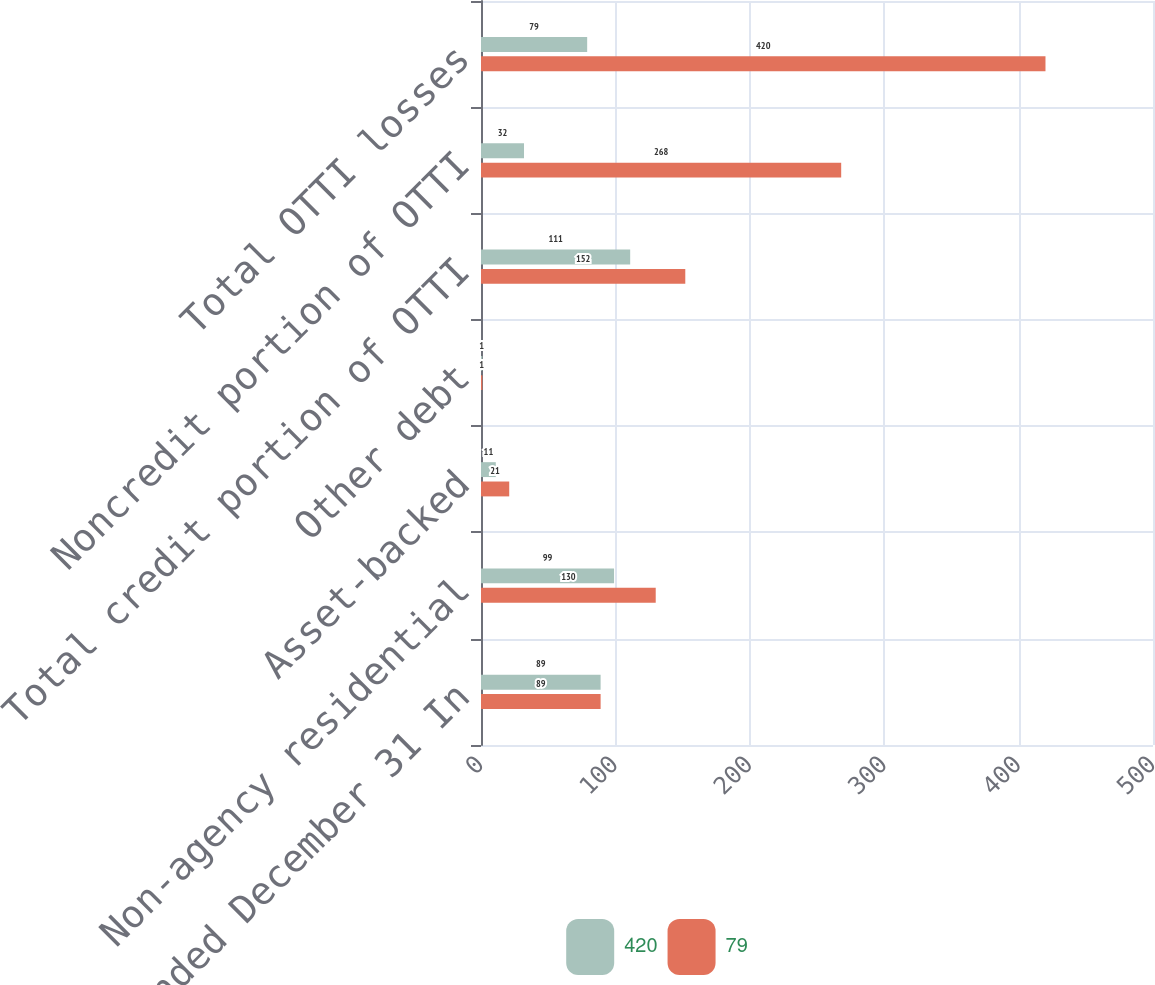Convert chart to OTSL. <chart><loc_0><loc_0><loc_500><loc_500><stacked_bar_chart><ecel><fcel>Year ended December 31 In<fcel>Non-agency residential<fcel>Asset-backed<fcel>Other debt<fcel>Total credit portion of OTTI<fcel>Noncredit portion of OTTI<fcel>Total OTTI losses<nl><fcel>420<fcel>89<fcel>99<fcel>11<fcel>1<fcel>111<fcel>32<fcel>79<nl><fcel>79<fcel>89<fcel>130<fcel>21<fcel>1<fcel>152<fcel>268<fcel>420<nl></chart> 